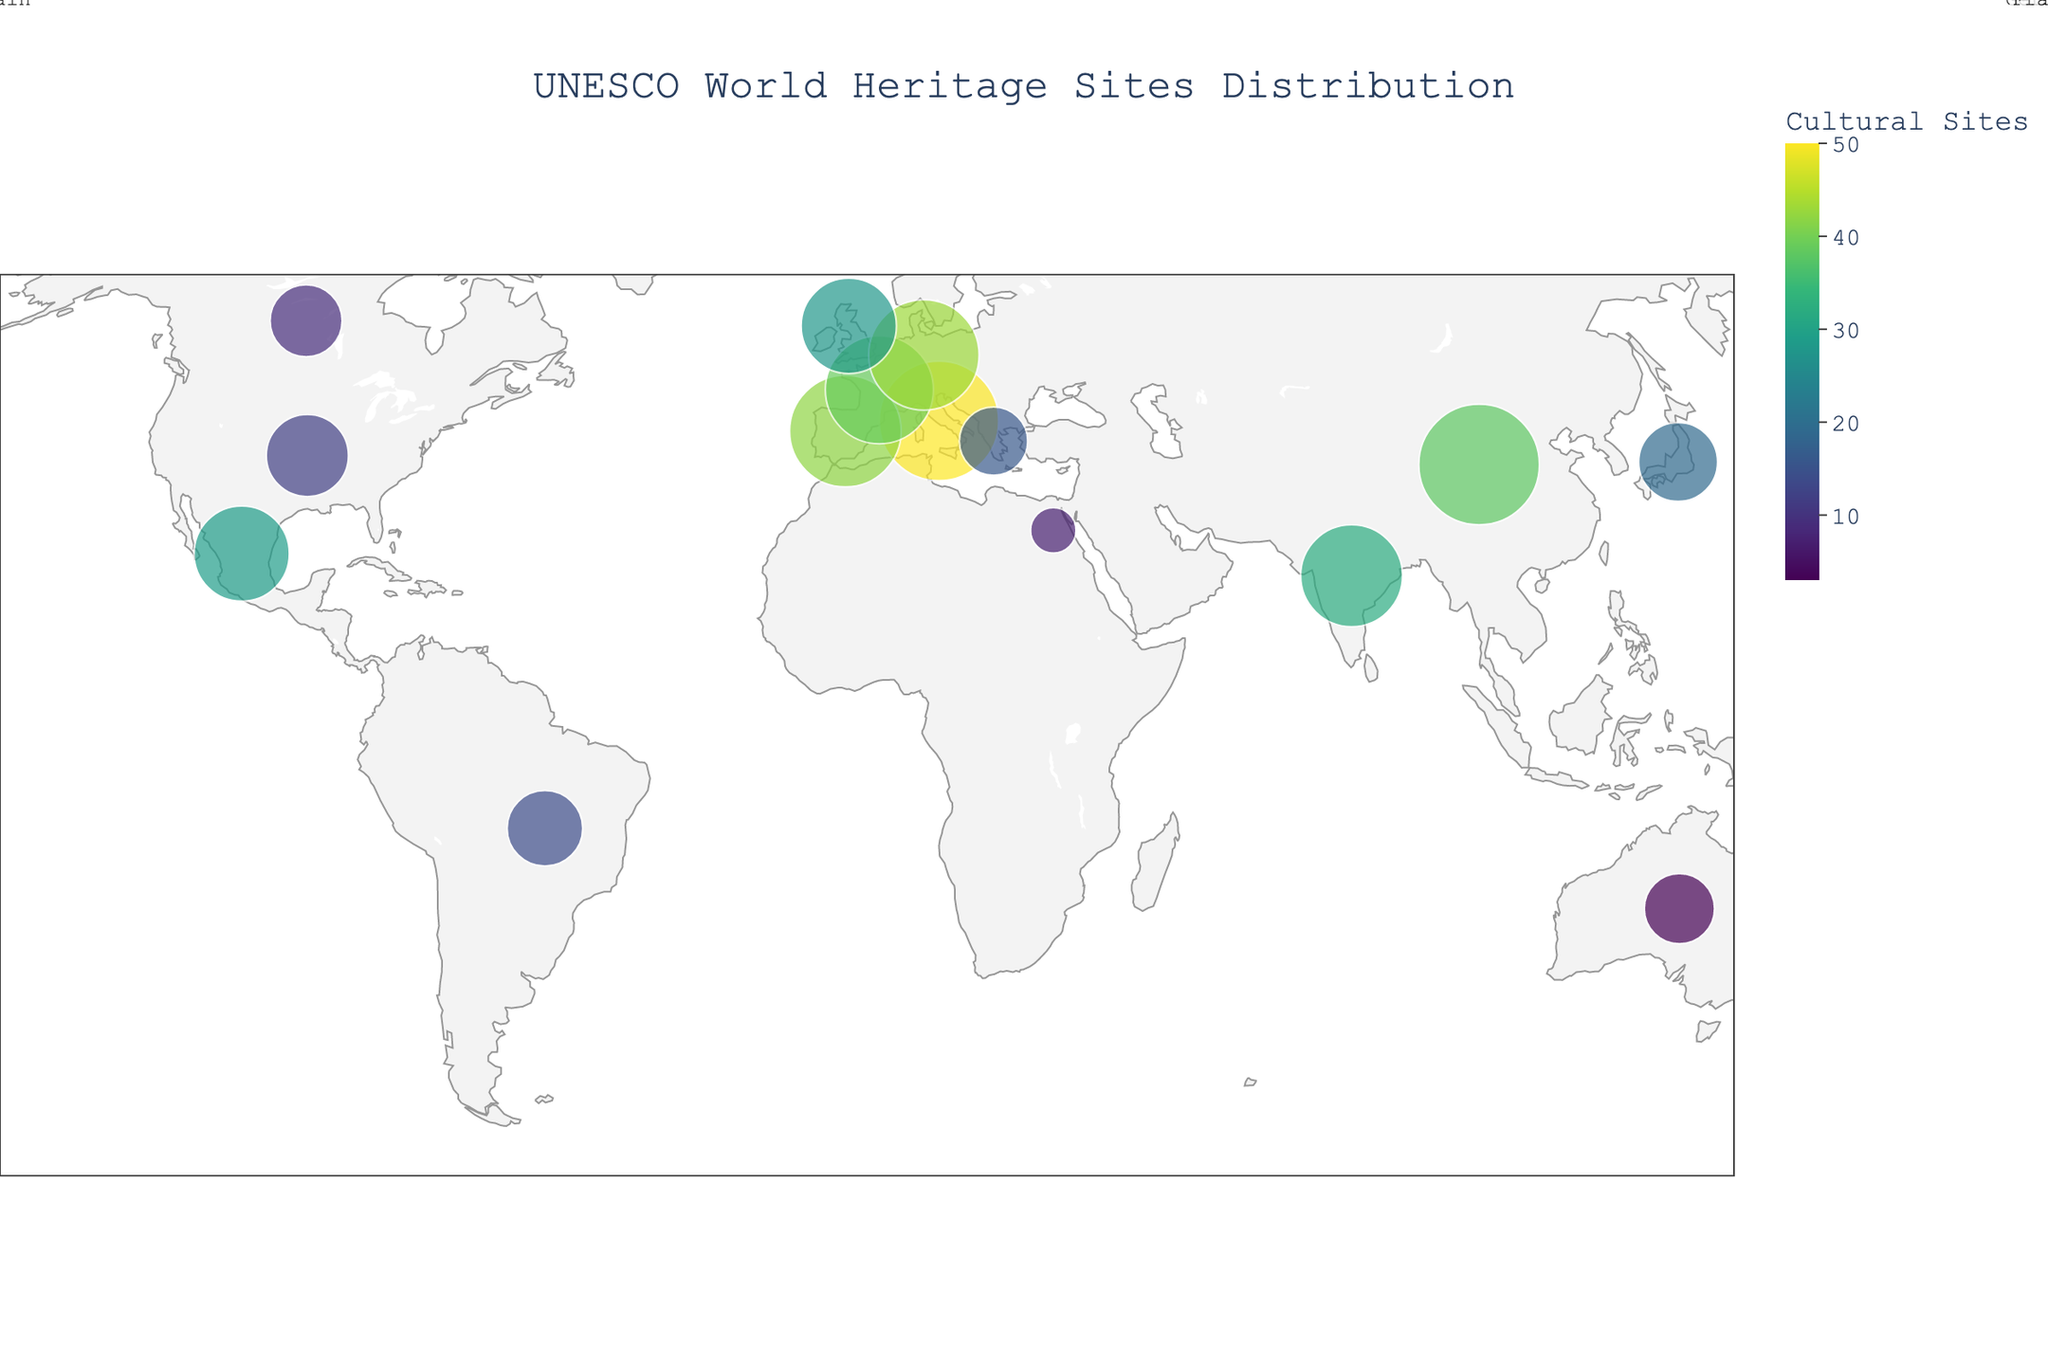Which country has the largest number of UNESCO World Heritage Sites? By looking at the plot, you will see that Italy has the largest markers, indicating the highest number of World Heritage Sites.
Answer: Italy How many Cultural Sites are there in Germany? The color and hover data of the geographical marker over Germany reveal that it has 43 Cultural Sites.
Answer: 43 Which country has more Natural Sites, China or the United States? Examining the hover data for China and the United States, you will see that China has 14 Natural Sites and the United States has 14. So they have an equal number of Natural Sites.
Answer: Equal How many Mixed Sites are there in Australia? According to the hover data when you select the marker over Australia, it indicates that Australia has 4 Mixed Sites.
Answer: 4 What is the average number of total UNESCO World Heritage Sites in the top three countries (by total sites)? Italy (55), China (56), and Germany (47) are the top three countries by total sites. The average is (55 + 56 + 47) / 3 = 52.67.
Answer: 52.67 Which country has fewer Cultural Sites, Canada or Brazil? By comparing the hover data of Canada and Brazil, we see that Canada has 9 Cultural Sites, while Brazil has 14 Cultural Sites. Therefore, Canada has fewer Cultural Sites.
Answer: Canada How many total sites does Japan have? By examining the plot and hovering over Japan, the data shows that Japan has a sum of 19 Cultural Sites, 5 Natural Sites, and 0 Mixed Sites, leading to a total of 24 sites.
Answer: 24 Which country in the Southern Hemisphere has the highest number of total UNESCO World Heritage Sites? By checking the markers below the equator, we can see that Australia, with a larger marker size, has the highest number of total sites in the Southern Hemisphere.
Answer: Australia What is the sum of Cultural and Natural Sites in France? Hovering over France, we see that it has 39 Cultural Sites and 5 Natural Sites. The sum of these is 39 + 5 = 44.
Answer: 44 What color represents the number of Cultural Sites? From the color scale bar, it is evident that the number of Cultural Sites is represented by shades on the Viridis color scale.
Answer: Viridis 